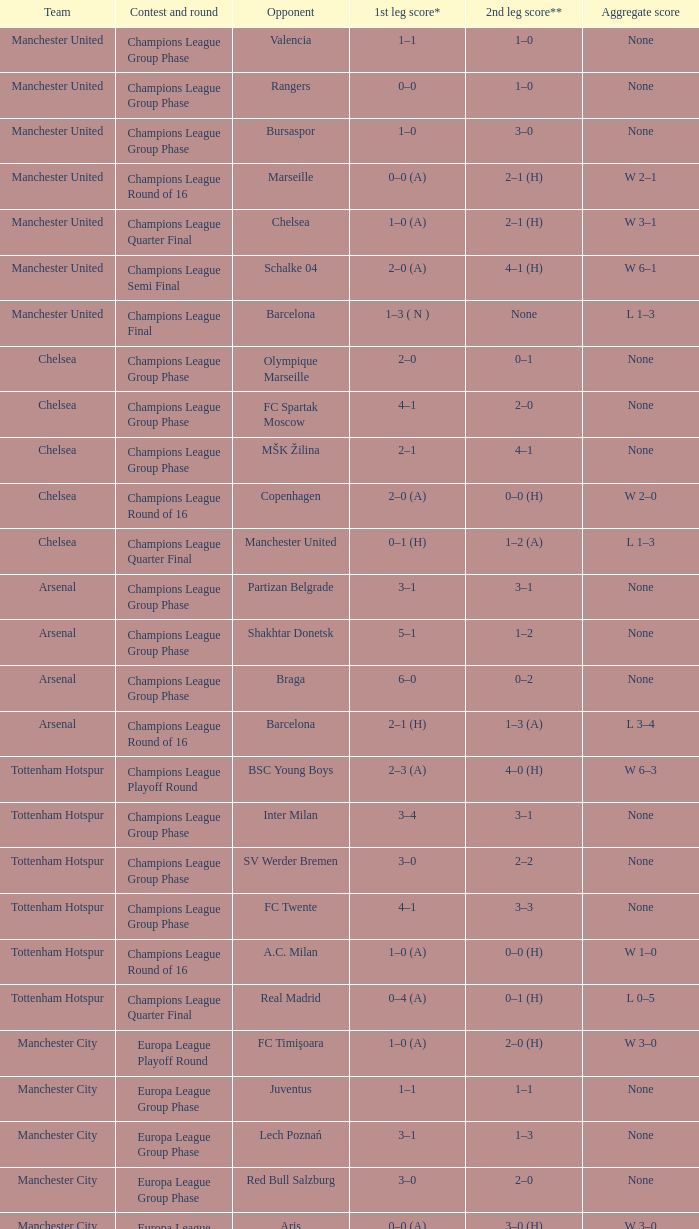How many goals did each one of the teams score in the first leg of the match between Liverpool and Trabzonspor? 1–0 (H). 